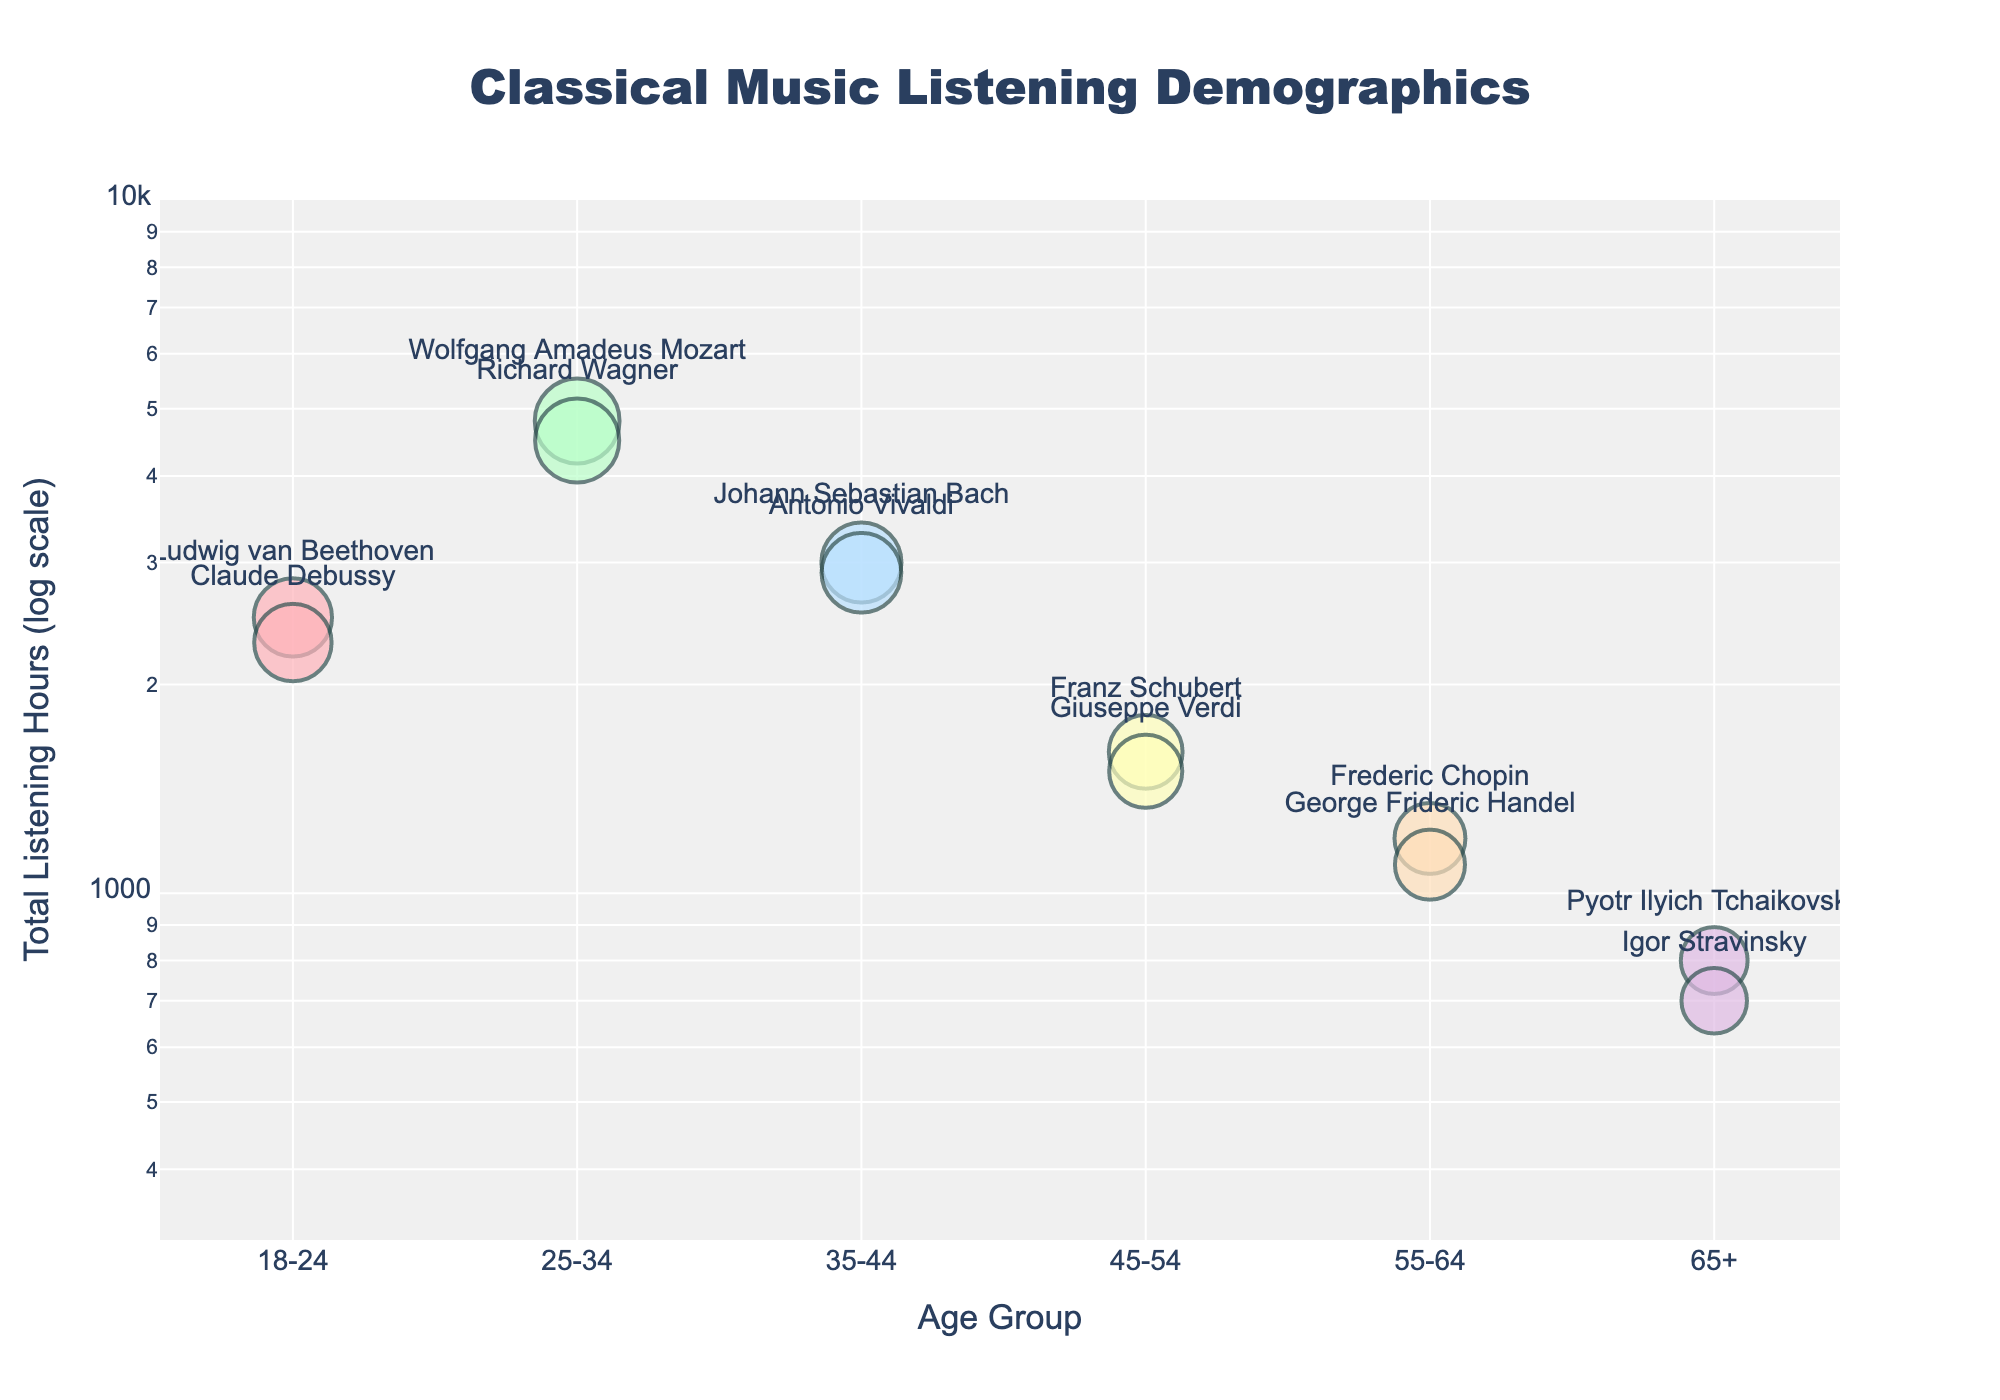what is the title of the scatter plot? The title is located at the top center of the figure and reads "Classical Music Listening Demographics".
Answer: Classical Music Listening Demographics how many composers are represented in the scatter plot? Each composer is represented by a unique marker on the scatter plot. By counting the number of different names, we can determine there are 12 composers.
Answer: 12 which composer has the highest total listening hours? The highest point on the y-axis will correspond to the highest total listening hours. Wolfgang Amadeus Mozart (25-34 age group) has the highest y-coordinate, which is 4800 listening hours.
Answer: Wolfgang Amadeus Mozart what is the total listening hours for 18-24 age group for both composers? The composers Ludwig van Beethoven and Claude Debussy are from the 18-24 age group. Their total listening hours are 2500 and 2300, respectively. Summing these up gives 2500 + 2300 = 4800.
Answer: 4800 which age group do most composers belong to: 25-34 or 65+? Only two age groups are compared here. By checking the number of markers, there are 2 composers for 65+ and 2 composers for 25-34, which shows they belong to an equal number of composers.
Answer: Equal what is the largest difference in total listening hours between age groups? Observing the maximum and minimum y-coordinates: the highest is 4800 (Mozart, 25-34) and the lowest is 700 (Stravinsky, 65+). The difference is 4800 - 700 = 4100.
Answer: 4100 how many composers appear in the 35-44 age group? To determine this, look for markers in the 35-44 category. Two composers, Johann Sebastian Bach and Antonio Vivaldi, appear in this group.
Answer: 2 which composer has the smallest total listening hours? The lowest point on the y-axis identifies the composer with the smallest listening hours, which is Igor Stravinsky with 700 hours in the 65+ age group.
Answer: Igor Stravinsky compare the total listening hours of the 55-64 age group to the 45-54 age group. Summing the listening hours for each age group: For 55-64, Frederic Chopin (1200) and George Frideric Handel (1100) yield 2300 hours. For 45-54, Franz Schubert (1600) and Giuseppe Verdi (1500) yield 3100 hours. Hence, 3100 (45-54) > 2300 (55-64).
Answer: 3100 vs 2300 how is the range of the y-axis represented in the scatter plot? The y-axis is set to a log scale ranging from log(2.5) to log(4). Logarithmic scaling distorts regular intervals for better presentation of data distribution.
Answer: log scale from 2.5 to 4 